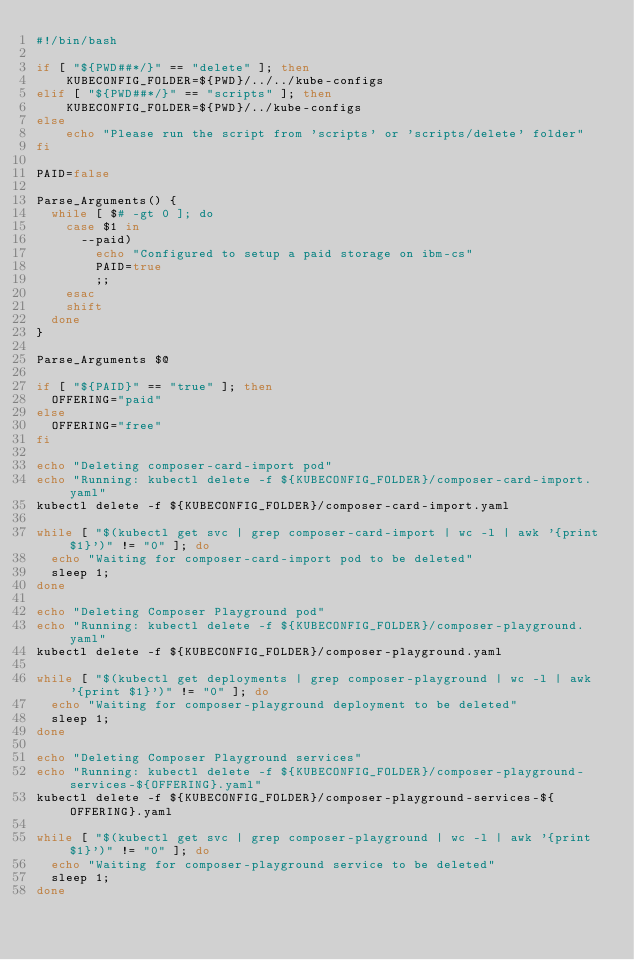Convert code to text. <code><loc_0><loc_0><loc_500><loc_500><_Bash_>#!/bin/bash

if [ "${PWD##*/}" == "delete" ]; then
    KUBECONFIG_FOLDER=${PWD}/../../kube-configs
elif [ "${PWD##*/}" == "scripts" ]; then
    KUBECONFIG_FOLDER=${PWD}/../kube-configs
else
    echo "Please run the script from 'scripts' or 'scripts/delete' folder"
fi

PAID=false

Parse_Arguments() {
	while [ $# -gt 0 ]; do
		case $1 in
			--paid)
				echo "Configured to setup a paid storage on ibm-cs"
				PAID=true
				;;
		esac
		shift
	done
}

Parse_Arguments $@

if [ "${PAID}" == "true" ]; then
	OFFERING="paid"
else
	OFFERING="free"
fi

echo "Deleting composer-card-import pod"
echo "Running: kubectl delete -f ${KUBECONFIG_FOLDER}/composer-card-import.yaml"
kubectl delete -f ${KUBECONFIG_FOLDER}/composer-card-import.yaml

while [ "$(kubectl get svc | grep composer-card-import | wc -l | awk '{print $1}')" != "0" ]; do
	echo "Waiting for composer-card-import pod to be deleted"
	sleep 1;
done

echo "Deleting Composer Playground pod"
echo "Running: kubectl delete -f ${KUBECONFIG_FOLDER}/composer-playground.yaml"
kubectl delete -f ${KUBECONFIG_FOLDER}/composer-playground.yaml

while [ "$(kubectl get deployments | grep composer-playground | wc -l | awk '{print $1}')" != "0" ]; do
	echo "Waiting for composer-playground deployment to be deleted"
	sleep 1;
done

echo "Deleting Composer Playground services"
echo "Running: kubectl delete -f ${KUBECONFIG_FOLDER}/composer-playground-services-${OFFERING}.yaml"
kubectl delete -f ${KUBECONFIG_FOLDER}/composer-playground-services-${OFFERING}.yaml

while [ "$(kubectl get svc | grep composer-playground | wc -l | awk '{print $1}')" != "0" ]; do
	echo "Waiting for composer-playground service to be deleted"
	sleep 1;
done
</code> 